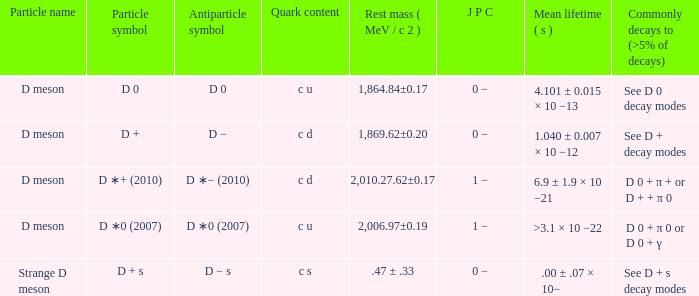What is the antiparticle symbol with a rest mess (mev/c2) of .47 ± .33? D − s. 